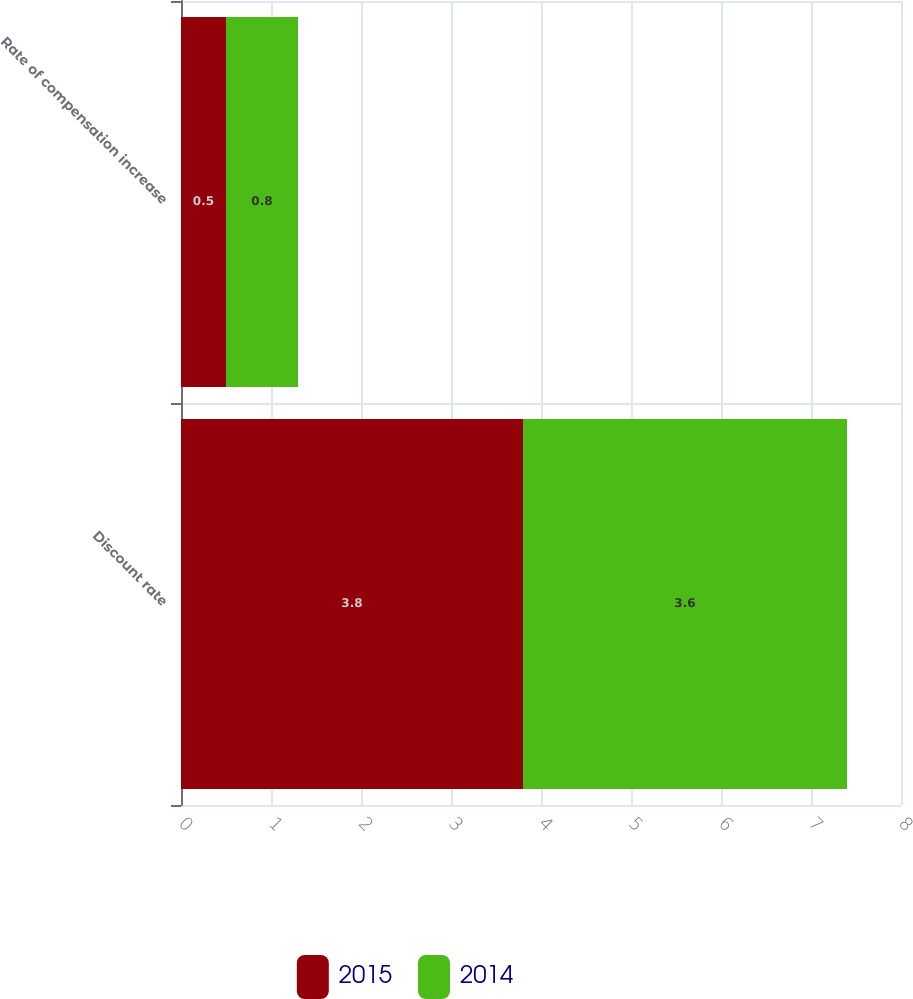Convert chart. <chart><loc_0><loc_0><loc_500><loc_500><stacked_bar_chart><ecel><fcel>Discount rate<fcel>Rate of compensation increase<nl><fcel>2015<fcel>3.8<fcel>0.5<nl><fcel>2014<fcel>3.6<fcel>0.8<nl></chart> 